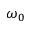<formula> <loc_0><loc_0><loc_500><loc_500>\omega _ { 0 }</formula> 